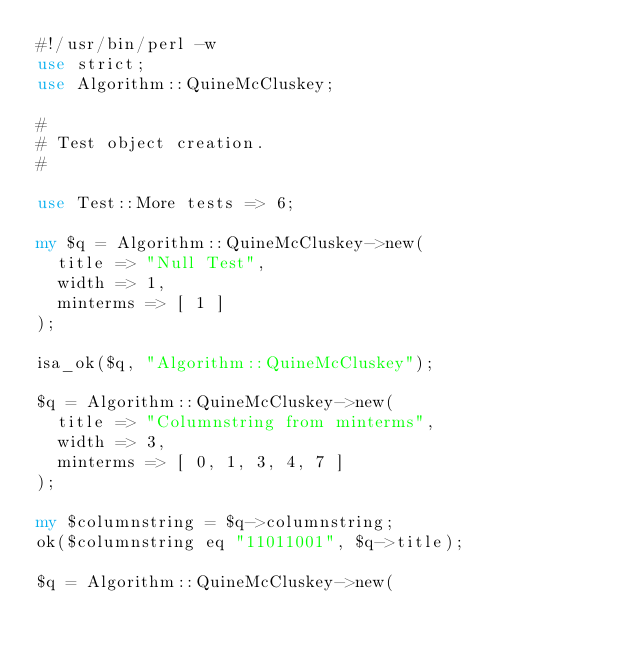<code> <loc_0><loc_0><loc_500><loc_500><_Perl_>#!/usr/bin/perl -w
use strict;
use Algorithm::QuineMcCluskey;

#
# Test object creation.
#

use Test::More tests => 6;

my $q = Algorithm::QuineMcCluskey->new(
	title => "Null Test",
	width => 1,
	minterms => [ 1 ]
);

isa_ok($q, "Algorithm::QuineMcCluskey");

$q = Algorithm::QuineMcCluskey->new(
	title => "Columnstring from minterms",
	width => 3,
	minterms => [ 0, 1, 3, 4, 7 ]
);

my $columnstring = $q->columnstring;
ok($columnstring eq "11011001", $q->title);

$q = Algorithm::QuineMcCluskey->new(</code> 